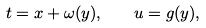<formula> <loc_0><loc_0><loc_500><loc_500>t = x + \omega ( y ) , \quad u = g ( y ) ,</formula> 